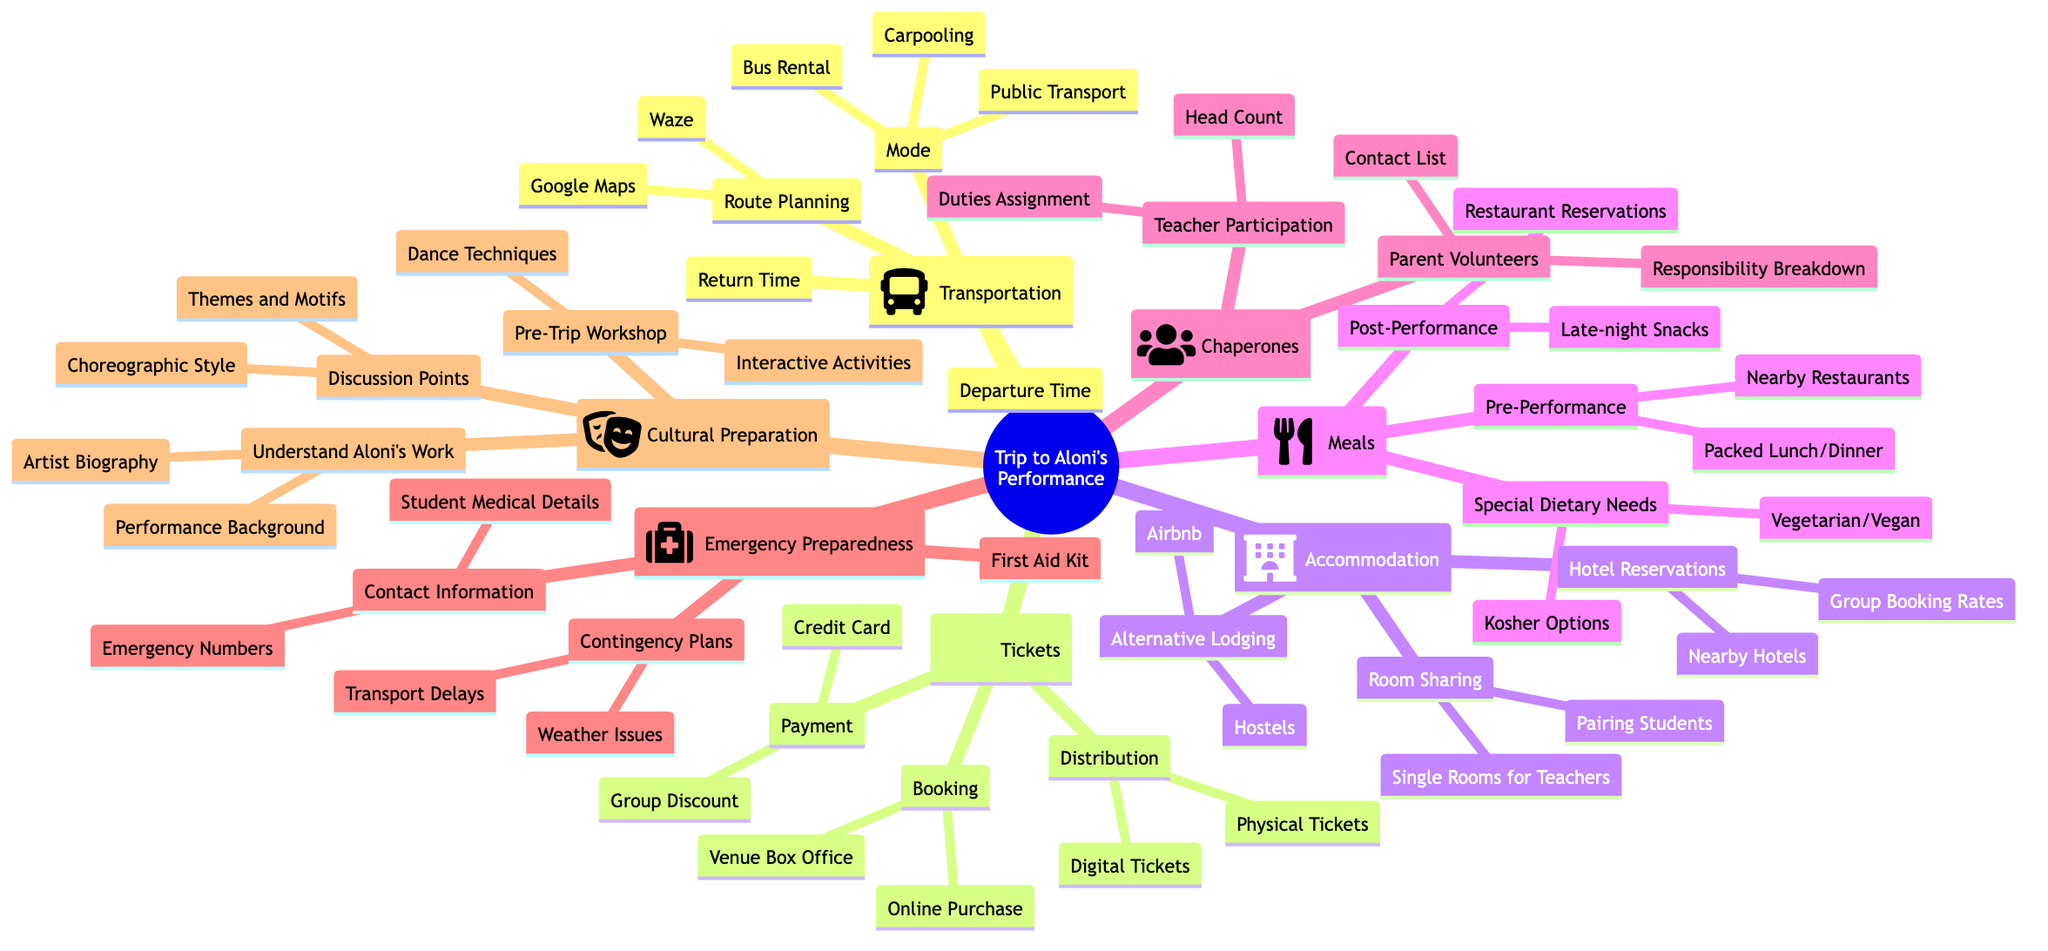What are the modes of transport available? The modes of transport are listed under the "Transportation" main topic. They include "Bus Rental," "Carpooling," and "Public Transport."
Answer: Bus Rental, Carpooling, Public Transport What type of dietary needs are considered for meals? Under the "Meals" section, special dietary needs mentioned are "Kosher Options" and "Vegetarian/Vegan Choices."
Answer: Kosher Options, Vegetarian/Vegan Choices How many subtopics are there under Accommodation? The "Accommodation" main topic includes three subtopics: "Hotel Reservations," "Alternative Lodging," and "Room Sharing," which totals three subtopics.
Answer: 3 What is included in Emergency Preparedness? The "Emergency Preparedness" main topic encompasses "Contact Information," "First Aid Kit," and "Contingency Plans." Therefore, the associated items are noted under these categories.
Answer: Contact Information, First Aid Kit, Contingency Plans What is one way to understand Aloni's work? Under "Cultural Preparation," one way to understand Aloni's work is to review the "Artist Biography," which provides information about the artist's background.
Answer: Artist Biography What are the two options for ticket booking? The "Tickets" main topic provides two options for booking: "Online Purchase" and "Venue Box Office." Both are listed under the "Booking" subtopic.
Answer: Online Purchase, Venue Box Office What should teachers do for Chaperones? In the "Chaperones" section, "Teacher Participation" involves handling a "Head Count" and "Duties Assignment" as part of their responsibilities.
Answer: Head Count, Duties Assignment What is a contingency plan for emergency preparedness? The "Contingency Plans" under "Emergency Preparedness" includes plans for "Weather-related Issues" and "Transport Delays," providing options for dealing with various emergencies.
Answer: Weather-related Issues, Transport Delays How can students be paired for lodging? In the "Room Sharing" subtopic under "Accommodation," students can be paired for lodging according to the suggested strategy listed: "Pairing Students."
Answer: Pairing Students 